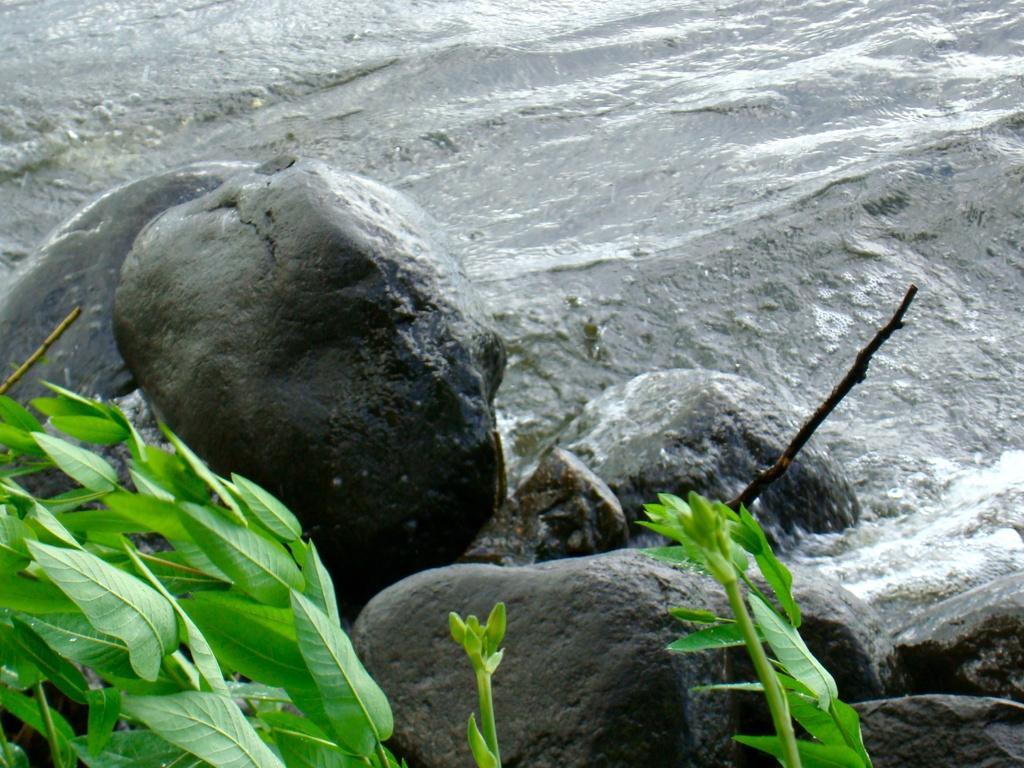Can you describe this image briefly? In this image we can see the water. We can also see some stones, leaves, buds and a branch of a tree beside the water. 